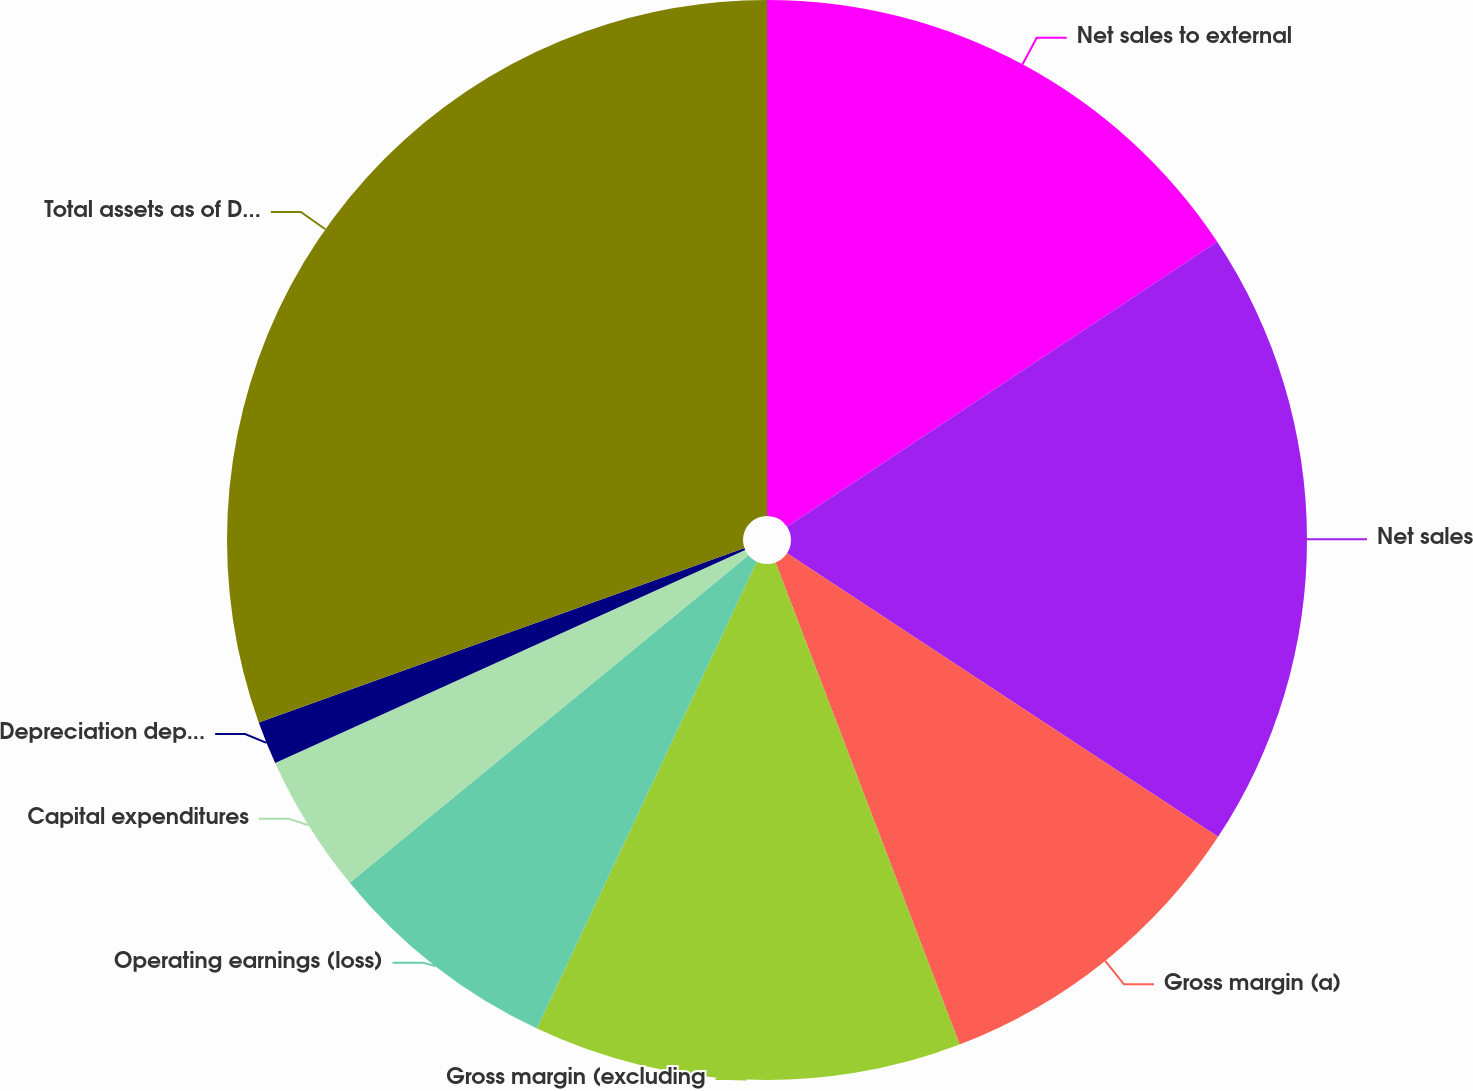Convert chart. <chart><loc_0><loc_0><loc_500><loc_500><pie_chart><fcel>Net sales to external<fcel>Net sales<fcel>Gross margin (a)<fcel>Gross margin (excluding<fcel>Operating earnings (loss)<fcel>Capital expenditures<fcel>Depreciation depletion and<fcel>Total assets as of December 31<nl><fcel>15.69%<fcel>18.57%<fcel>9.93%<fcel>12.81%<fcel>7.05%<fcel>4.17%<fcel>1.29%<fcel>30.48%<nl></chart> 